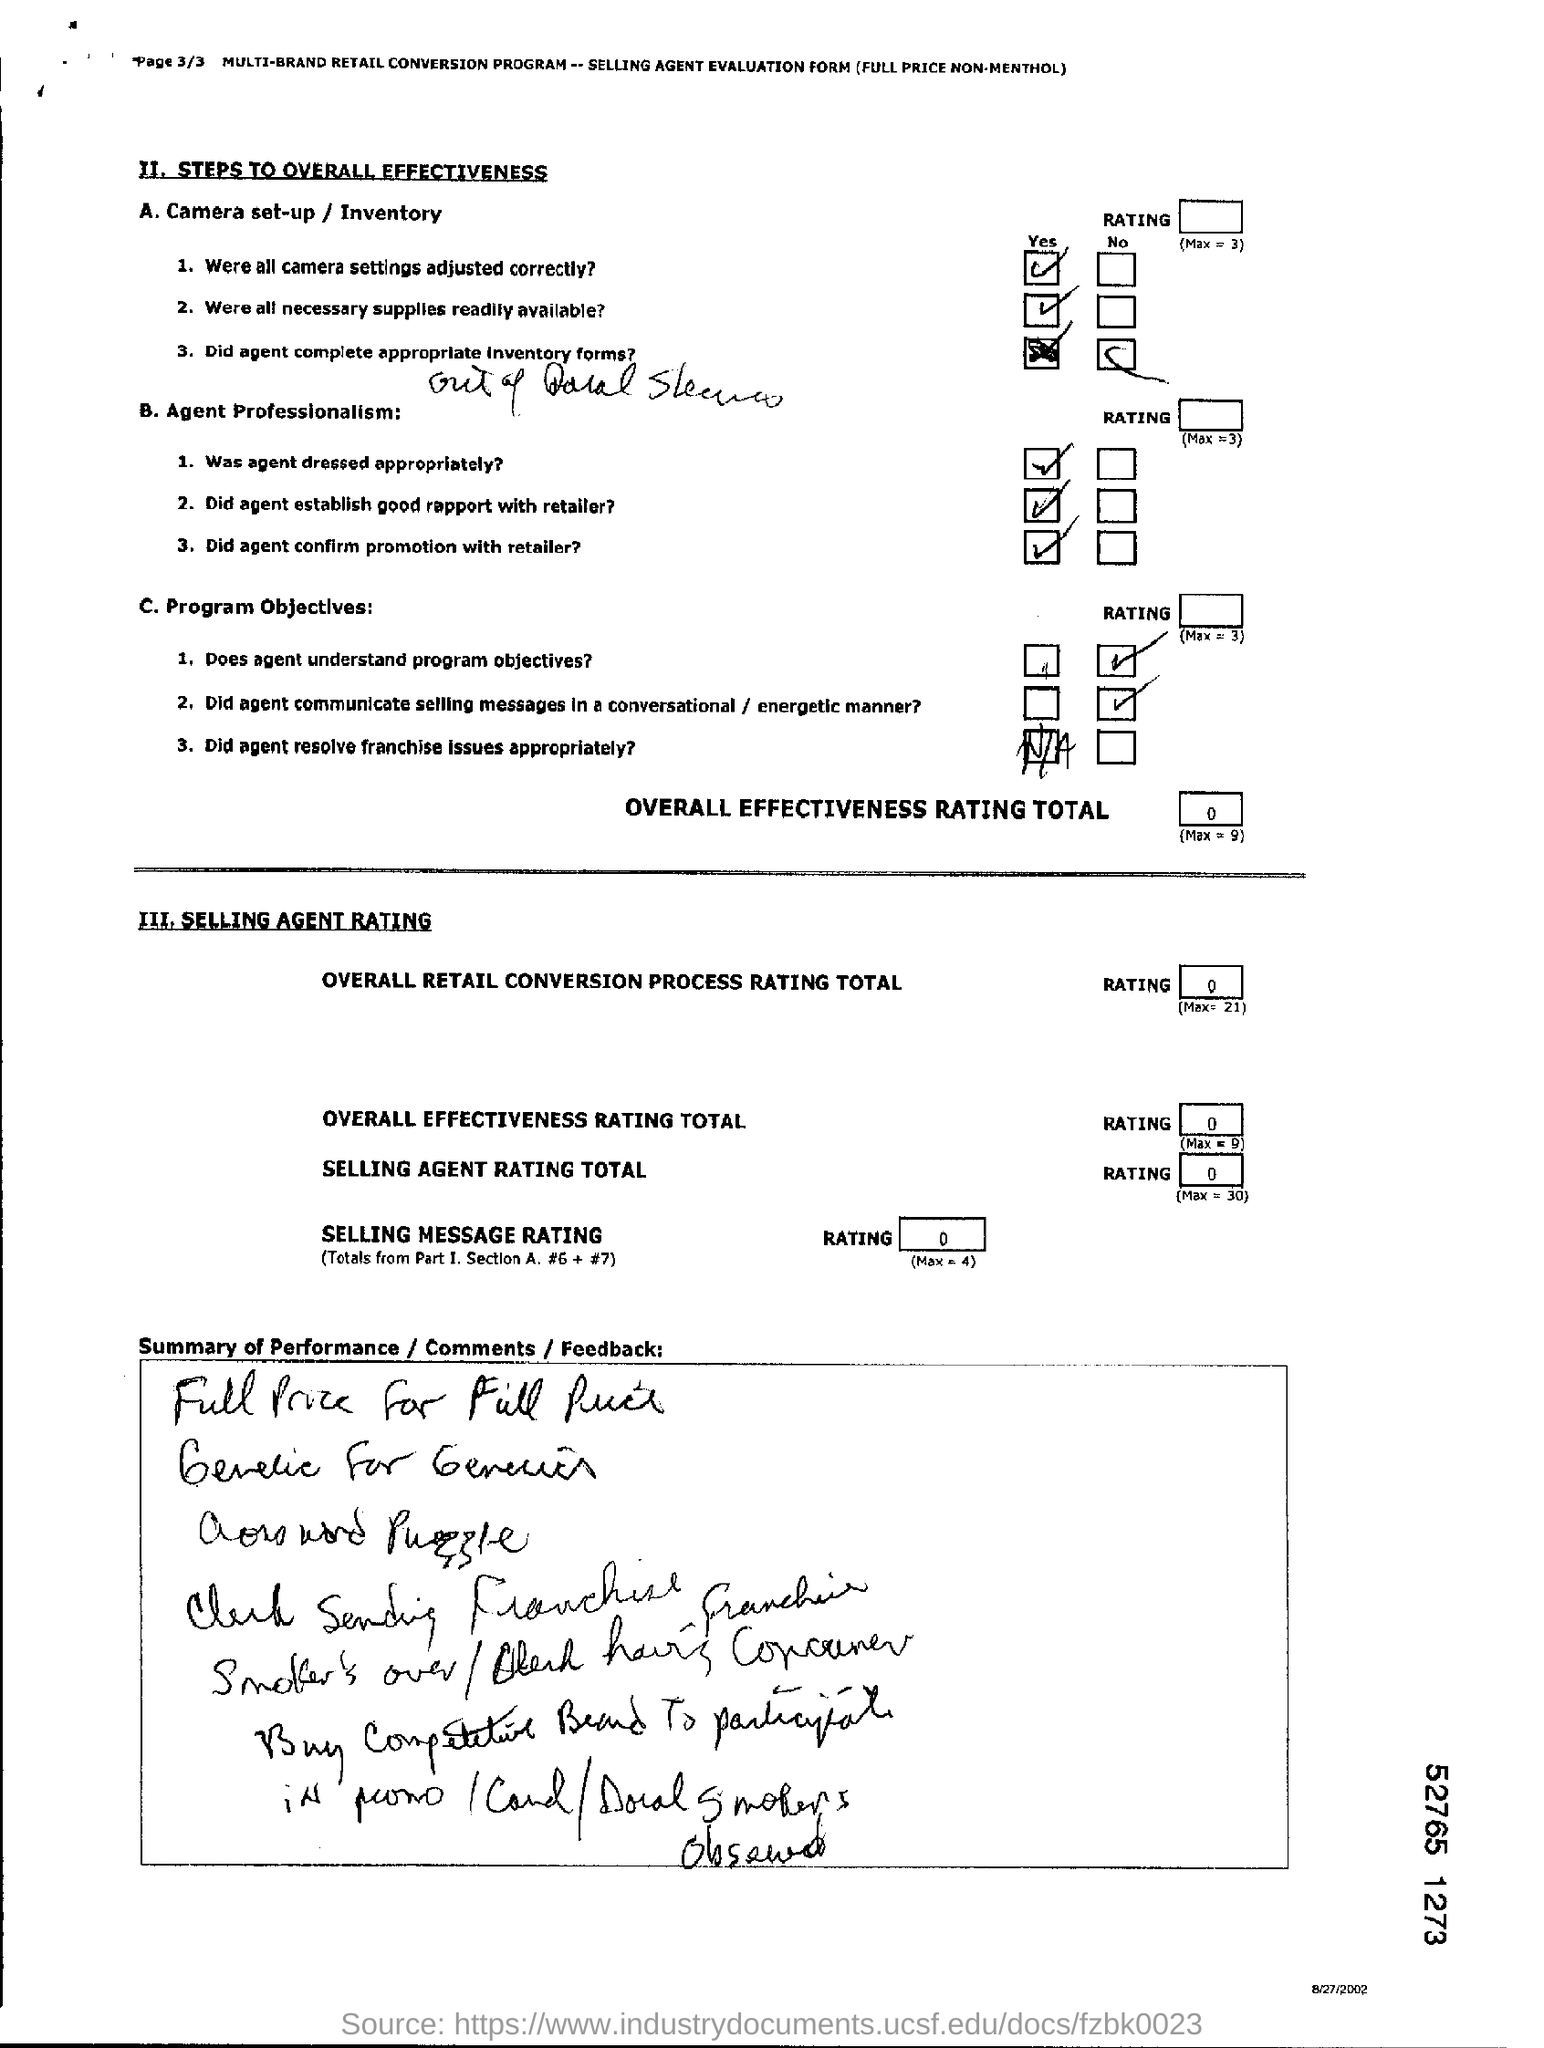Point out several critical features in this image. The camera settings were adjusted correctly, and the resulting images were of high quality. The agent does not understand the program objectives. 